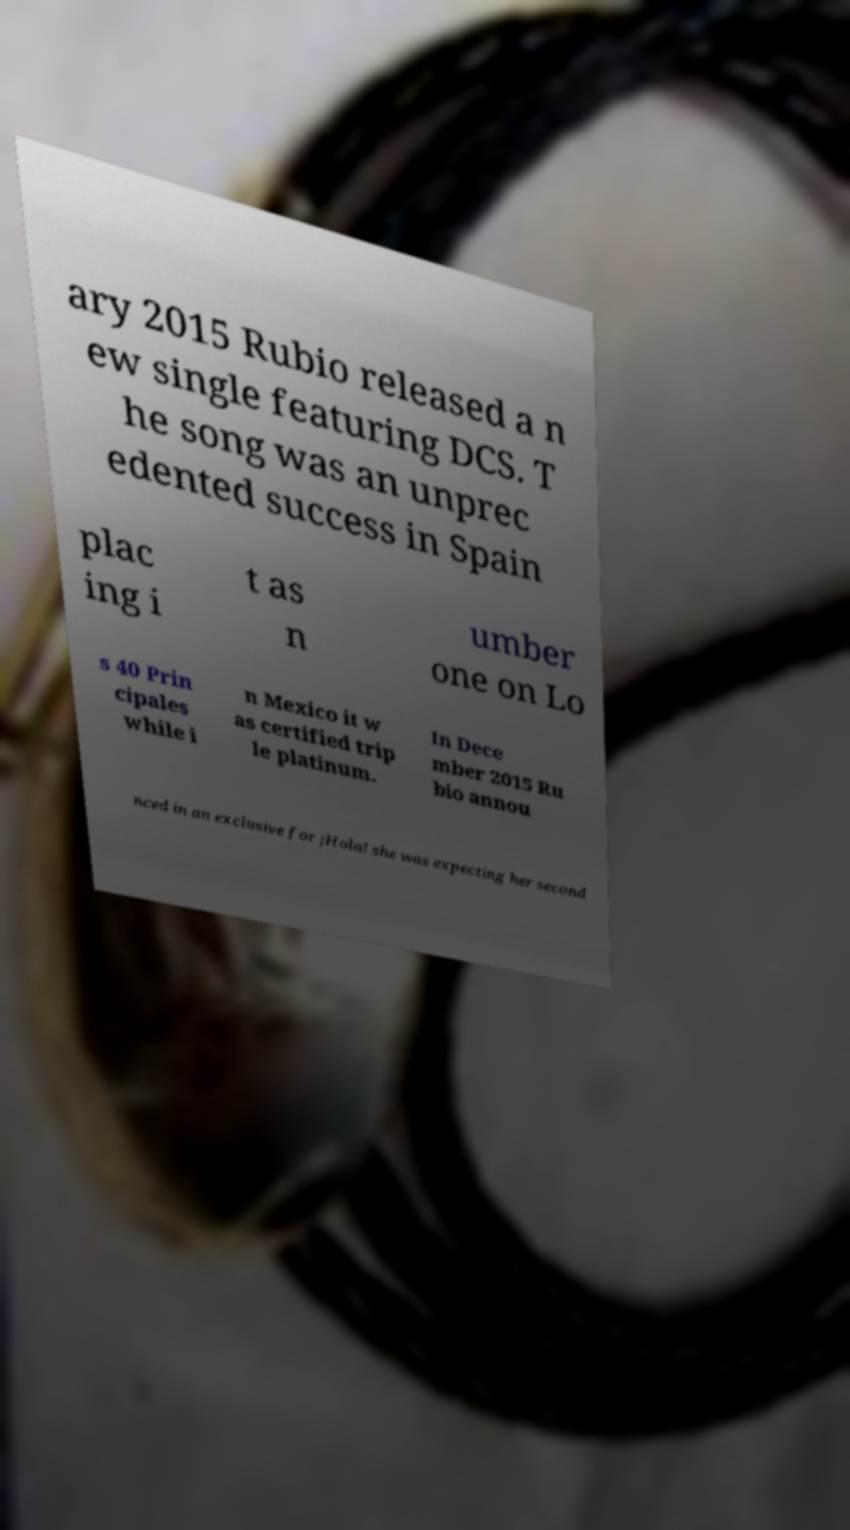What messages or text are displayed in this image? I need them in a readable, typed format. ary 2015 Rubio released a n ew single featuring DCS. T he song was an unprec edented success in Spain plac ing i t as n umber one on Lo s 40 Prin cipales while i n Mexico it w as certified trip le platinum. In Dece mber 2015 Ru bio annou nced in an exclusive for ¡Hola! she was expecting her second 